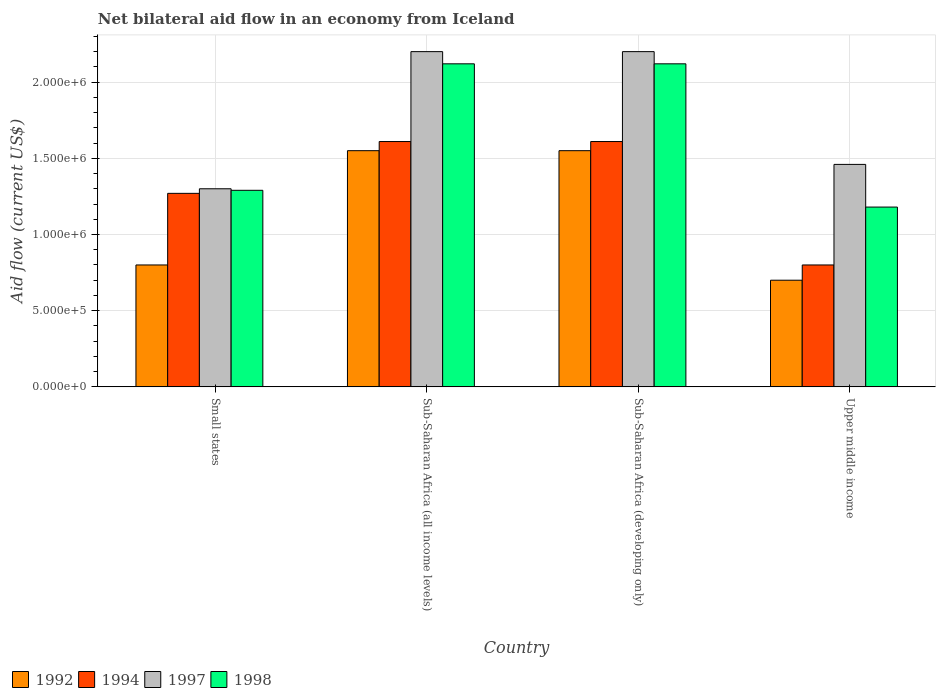How many different coloured bars are there?
Your answer should be very brief. 4. Are the number of bars per tick equal to the number of legend labels?
Your response must be concise. Yes. What is the label of the 4th group of bars from the left?
Make the answer very short. Upper middle income. What is the net bilateral aid flow in 1997 in Upper middle income?
Your response must be concise. 1.46e+06. Across all countries, what is the maximum net bilateral aid flow in 1992?
Make the answer very short. 1.55e+06. In which country was the net bilateral aid flow in 1994 maximum?
Provide a succinct answer. Sub-Saharan Africa (all income levels). In which country was the net bilateral aid flow in 1997 minimum?
Offer a very short reply. Small states. What is the total net bilateral aid flow in 1997 in the graph?
Make the answer very short. 7.16e+06. What is the difference between the net bilateral aid flow in 1998 in Small states and that in Sub-Saharan Africa (all income levels)?
Provide a short and direct response. -8.30e+05. What is the average net bilateral aid flow in 1992 per country?
Your answer should be very brief. 1.15e+06. What is the difference between the net bilateral aid flow of/in 1997 and net bilateral aid flow of/in 1998 in Sub-Saharan Africa (all income levels)?
Make the answer very short. 8.00e+04. What is the ratio of the net bilateral aid flow in 1992 in Small states to that in Sub-Saharan Africa (all income levels)?
Provide a short and direct response. 0.52. Is the net bilateral aid flow in 1994 in Small states less than that in Sub-Saharan Africa (all income levels)?
Your answer should be compact. Yes. Is the difference between the net bilateral aid flow in 1997 in Small states and Sub-Saharan Africa (all income levels) greater than the difference between the net bilateral aid flow in 1998 in Small states and Sub-Saharan Africa (all income levels)?
Make the answer very short. No. What is the difference between the highest and the second highest net bilateral aid flow in 1992?
Offer a very short reply. 7.50e+05. What is the difference between the highest and the lowest net bilateral aid flow in 1998?
Keep it short and to the point. 9.40e+05. In how many countries, is the net bilateral aid flow in 1998 greater than the average net bilateral aid flow in 1998 taken over all countries?
Your answer should be compact. 2. Is it the case that in every country, the sum of the net bilateral aid flow in 1997 and net bilateral aid flow in 1998 is greater than the sum of net bilateral aid flow in 1992 and net bilateral aid flow in 1994?
Offer a very short reply. No. How many bars are there?
Your answer should be very brief. 16. Are the values on the major ticks of Y-axis written in scientific E-notation?
Make the answer very short. Yes. Does the graph contain any zero values?
Offer a very short reply. No. Does the graph contain grids?
Ensure brevity in your answer.  Yes. How are the legend labels stacked?
Ensure brevity in your answer.  Horizontal. What is the title of the graph?
Your response must be concise. Net bilateral aid flow in an economy from Iceland. What is the label or title of the X-axis?
Your response must be concise. Country. What is the label or title of the Y-axis?
Provide a short and direct response. Aid flow (current US$). What is the Aid flow (current US$) of 1992 in Small states?
Give a very brief answer. 8.00e+05. What is the Aid flow (current US$) of 1994 in Small states?
Ensure brevity in your answer.  1.27e+06. What is the Aid flow (current US$) of 1997 in Small states?
Keep it short and to the point. 1.30e+06. What is the Aid flow (current US$) of 1998 in Small states?
Make the answer very short. 1.29e+06. What is the Aid flow (current US$) of 1992 in Sub-Saharan Africa (all income levels)?
Your answer should be compact. 1.55e+06. What is the Aid flow (current US$) of 1994 in Sub-Saharan Africa (all income levels)?
Make the answer very short. 1.61e+06. What is the Aid flow (current US$) of 1997 in Sub-Saharan Africa (all income levels)?
Offer a very short reply. 2.20e+06. What is the Aid flow (current US$) of 1998 in Sub-Saharan Africa (all income levels)?
Your response must be concise. 2.12e+06. What is the Aid flow (current US$) of 1992 in Sub-Saharan Africa (developing only)?
Your answer should be very brief. 1.55e+06. What is the Aid flow (current US$) of 1994 in Sub-Saharan Africa (developing only)?
Ensure brevity in your answer.  1.61e+06. What is the Aid flow (current US$) of 1997 in Sub-Saharan Africa (developing only)?
Give a very brief answer. 2.20e+06. What is the Aid flow (current US$) in 1998 in Sub-Saharan Africa (developing only)?
Your answer should be compact. 2.12e+06. What is the Aid flow (current US$) in 1992 in Upper middle income?
Provide a succinct answer. 7.00e+05. What is the Aid flow (current US$) in 1994 in Upper middle income?
Ensure brevity in your answer.  8.00e+05. What is the Aid flow (current US$) of 1997 in Upper middle income?
Your answer should be very brief. 1.46e+06. What is the Aid flow (current US$) in 1998 in Upper middle income?
Provide a short and direct response. 1.18e+06. Across all countries, what is the maximum Aid flow (current US$) of 1992?
Give a very brief answer. 1.55e+06. Across all countries, what is the maximum Aid flow (current US$) in 1994?
Provide a succinct answer. 1.61e+06. Across all countries, what is the maximum Aid flow (current US$) of 1997?
Keep it short and to the point. 2.20e+06. Across all countries, what is the maximum Aid flow (current US$) of 1998?
Your answer should be very brief. 2.12e+06. Across all countries, what is the minimum Aid flow (current US$) in 1997?
Offer a very short reply. 1.30e+06. Across all countries, what is the minimum Aid flow (current US$) of 1998?
Provide a short and direct response. 1.18e+06. What is the total Aid flow (current US$) in 1992 in the graph?
Your response must be concise. 4.60e+06. What is the total Aid flow (current US$) in 1994 in the graph?
Provide a succinct answer. 5.29e+06. What is the total Aid flow (current US$) of 1997 in the graph?
Offer a terse response. 7.16e+06. What is the total Aid flow (current US$) of 1998 in the graph?
Offer a very short reply. 6.71e+06. What is the difference between the Aid flow (current US$) in 1992 in Small states and that in Sub-Saharan Africa (all income levels)?
Keep it short and to the point. -7.50e+05. What is the difference between the Aid flow (current US$) in 1994 in Small states and that in Sub-Saharan Africa (all income levels)?
Keep it short and to the point. -3.40e+05. What is the difference between the Aid flow (current US$) in 1997 in Small states and that in Sub-Saharan Africa (all income levels)?
Offer a very short reply. -9.00e+05. What is the difference between the Aid flow (current US$) of 1998 in Small states and that in Sub-Saharan Africa (all income levels)?
Give a very brief answer. -8.30e+05. What is the difference between the Aid flow (current US$) in 1992 in Small states and that in Sub-Saharan Africa (developing only)?
Ensure brevity in your answer.  -7.50e+05. What is the difference between the Aid flow (current US$) of 1997 in Small states and that in Sub-Saharan Africa (developing only)?
Your answer should be compact. -9.00e+05. What is the difference between the Aid flow (current US$) in 1998 in Small states and that in Sub-Saharan Africa (developing only)?
Your answer should be very brief. -8.30e+05. What is the difference between the Aid flow (current US$) in 1994 in Small states and that in Upper middle income?
Your answer should be compact. 4.70e+05. What is the difference between the Aid flow (current US$) in 1992 in Sub-Saharan Africa (all income levels) and that in Sub-Saharan Africa (developing only)?
Provide a succinct answer. 0. What is the difference between the Aid flow (current US$) in 1992 in Sub-Saharan Africa (all income levels) and that in Upper middle income?
Give a very brief answer. 8.50e+05. What is the difference between the Aid flow (current US$) of 1994 in Sub-Saharan Africa (all income levels) and that in Upper middle income?
Offer a very short reply. 8.10e+05. What is the difference between the Aid flow (current US$) in 1997 in Sub-Saharan Africa (all income levels) and that in Upper middle income?
Keep it short and to the point. 7.40e+05. What is the difference between the Aid flow (current US$) of 1998 in Sub-Saharan Africa (all income levels) and that in Upper middle income?
Keep it short and to the point. 9.40e+05. What is the difference between the Aid flow (current US$) in 1992 in Sub-Saharan Africa (developing only) and that in Upper middle income?
Your response must be concise. 8.50e+05. What is the difference between the Aid flow (current US$) of 1994 in Sub-Saharan Africa (developing only) and that in Upper middle income?
Provide a succinct answer. 8.10e+05. What is the difference between the Aid flow (current US$) of 1997 in Sub-Saharan Africa (developing only) and that in Upper middle income?
Give a very brief answer. 7.40e+05. What is the difference between the Aid flow (current US$) in 1998 in Sub-Saharan Africa (developing only) and that in Upper middle income?
Your answer should be very brief. 9.40e+05. What is the difference between the Aid flow (current US$) in 1992 in Small states and the Aid flow (current US$) in 1994 in Sub-Saharan Africa (all income levels)?
Keep it short and to the point. -8.10e+05. What is the difference between the Aid flow (current US$) of 1992 in Small states and the Aid flow (current US$) of 1997 in Sub-Saharan Africa (all income levels)?
Keep it short and to the point. -1.40e+06. What is the difference between the Aid flow (current US$) of 1992 in Small states and the Aid flow (current US$) of 1998 in Sub-Saharan Africa (all income levels)?
Offer a very short reply. -1.32e+06. What is the difference between the Aid flow (current US$) of 1994 in Small states and the Aid flow (current US$) of 1997 in Sub-Saharan Africa (all income levels)?
Offer a terse response. -9.30e+05. What is the difference between the Aid flow (current US$) in 1994 in Small states and the Aid flow (current US$) in 1998 in Sub-Saharan Africa (all income levels)?
Provide a succinct answer. -8.50e+05. What is the difference between the Aid flow (current US$) of 1997 in Small states and the Aid flow (current US$) of 1998 in Sub-Saharan Africa (all income levels)?
Keep it short and to the point. -8.20e+05. What is the difference between the Aid flow (current US$) of 1992 in Small states and the Aid flow (current US$) of 1994 in Sub-Saharan Africa (developing only)?
Your answer should be very brief. -8.10e+05. What is the difference between the Aid flow (current US$) of 1992 in Small states and the Aid flow (current US$) of 1997 in Sub-Saharan Africa (developing only)?
Your answer should be compact. -1.40e+06. What is the difference between the Aid flow (current US$) of 1992 in Small states and the Aid flow (current US$) of 1998 in Sub-Saharan Africa (developing only)?
Your answer should be very brief. -1.32e+06. What is the difference between the Aid flow (current US$) of 1994 in Small states and the Aid flow (current US$) of 1997 in Sub-Saharan Africa (developing only)?
Your response must be concise. -9.30e+05. What is the difference between the Aid flow (current US$) of 1994 in Small states and the Aid flow (current US$) of 1998 in Sub-Saharan Africa (developing only)?
Provide a succinct answer. -8.50e+05. What is the difference between the Aid flow (current US$) in 1997 in Small states and the Aid flow (current US$) in 1998 in Sub-Saharan Africa (developing only)?
Your response must be concise. -8.20e+05. What is the difference between the Aid flow (current US$) of 1992 in Small states and the Aid flow (current US$) of 1994 in Upper middle income?
Offer a very short reply. 0. What is the difference between the Aid flow (current US$) in 1992 in Small states and the Aid flow (current US$) in 1997 in Upper middle income?
Ensure brevity in your answer.  -6.60e+05. What is the difference between the Aid flow (current US$) in 1992 in Small states and the Aid flow (current US$) in 1998 in Upper middle income?
Offer a terse response. -3.80e+05. What is the difference between the Aid flow (current US$) of 1994 in Small states and the Aid flow (current US$) of 1997 in Upper middle income?
Ensure brevity in your answer.  -1.90e+05. What is the difference between the Aid flow (current US$) of 1992 in Sub-Saharan Africa (all income levels) and the Aid flow (current US$) of 1997 in Sub-Saharan Africa (developing only)?
Your answer should be compact. -6.50e+05. What is the difference between the Aid flow (current US$) of 1992 in Sub-Saharan Africa (all income levels) and the Aid flow (current US$) of 1998 in Sub-Saharan Africa (developing only)?
Your answer should be compact. -5.70e+05. What is the difference between the Aid flow (current US$) in 1994 in Sub-Saharan Africa (all income levels) and the Aid flow (current US$) in 1997 in Sub-Saharan Africa (developing only)?
Give a very brief answer. -5.90e+05. What is the difference between the Aid flow (current US$) in 1994 in Sub-Saharan Africa (all income levels) and the Aid flow (current US$) in 1998 in Sub-Saharan Africa (developing only)?
Make the answer very short. -5.10e+05. What is the difference between the Aid flow (current US$) in 1997 in Sub-Saharan Africa (all income levels) and the Aid flow (current US$) in 1998 in Sub-Saharan Africa (developing only)?
Offer a terse response. 8.00e+04. What is the difference between the Aid flow (current US$) in 1992 in Sub-Saharan Africa (all income levels) and the Aid flow (current US$) in 1994 in Upper middle income?
Offer a very short reply. 7.50e+05. What is the difference between the Aid flow (current US$) of 1992 in Sub-Saharan Africa (all income levels) and the Aid flow (current US$) of 1998 in Upper middle income?
Your answer should be very brief. 3.70e+05. What is the difference between the Aid flow (current US$) in 1997 in Sub-Saharan Africa (all income levels) and the Aid flow (current US$) in 1998 in Upper middle income?
Give a very brief answer. 1.02e+06. What is the difference between the Aid flow (current US$) in 1992 in Sub-Saharan Africa (developing only) and the Aid flow (current US$) in 1994 in Upper middle income?
Provide a short and direct response. 7.50e+05. What is the difference between the Aid flow (current US$) in 1992 in Sub-Saharan Africa (developing only) and the Aid flow (current US$) in 1997 in Upper middle income?
Offer a terse response. 9.00e+04. What is the difference between the Aid flow (current US$) in 1992 in Sub-Saharan Africa (developing only) and the Aid flow (current US$) in 1998 in Upper middle income?
Offer a very short reply. 3.70e+05. What is the difference between the Aid flow (current US$) in 1994 in Sub-Saharan Africa (developing only) and the Aid flow (current US$) in 1998 in Upper middle income?
Provide a short and direct response. 4.30e+05. What is the difference between the Aid flow (current US$) in 1997 in Sub-Saharan Africa (developing only) and the Aid flow (current US$) in 1998 in Upper middle income?
Ensure brevity in your answer.  1.02e+06. What is the average Aid flow (current US$) of 1992 per country?
Your answer should be very brief. 1.15e+06. What is the average Aid flow (current US$) in 1994 per country?
Offer a terse response. 1.32e+06. What is the average Aid flow (current US$) in 1997 per country?
Ensure brevity in your answer.  1.79e+06. What is the average Aid flow (current US$) in 1998 per country?
Ensure brevity in your answer.  1.68e+06. What is the difference between the Aid flow (current US$) in 1992 and Aid flow (current US$) in 1994 in Small states?
Make the answer very short. -4.70e+05. What is the difference between the Aid flow (current US$) in 1992 and Aid flow (current US$) in 1997 in Small states?
Your answer should be compact. -5.00e+05. What is the difference between the Aid flow (current US$) in 1992 and Aid flow (current US$) in 1998 in Small states?
Make the answer very short. -4.90e+05. What is the difference between the Aid flow (current US$) of 1997 and Aid flow (current US$) of 1998 in Small states?
Ensure brevity in your answer.  10000. What is the difference between the Aid flow (current US$) in 1992 and Aid flow (current US$) in 1994 in Sub-Saharan Africa (all income levels)?
Your response must be concise. -6.00e+04. What is the difference between the Aid flow (current US$) in 1992 and Aid flow (current US$) in 1997 in Sub-Saharan Africa (all income levels)?
Your answer should be very brief. -6.50e+05. What is the difference between the Aid flow (current US$) in 1992 and Aid flow (current US$) in 1998 in Sub-Saharan Africa (all income levels)?
Provide a short and direct response. -5.70e+05. What is the difference between the Aid flow (current US$) of 1994 and Aid flow (current US$) of 1997 in Sub-Saharan Africa (all income levels)?
Provide a succinct answer. -5.90e+05. What is the difference between the Aid flow (current US$) in 1994 and Aid flow (current US$) in 1998 in Sub-Saharan Africa (all income levels)?
Provide a short and direct response. -5.10e+05. What is the difference between the Aid flow (current US$) in 1997 and Aid flow (current US$) in 1998 in Sub-Saharan Africa (all income levels)?
Provide a succinct answer. 8.00e+04. What is the difference between the Aid flow (current US$) of 1992 and Aid flow (current US$) of 1994 in Sub-Saharan Africa (developing only)?
Your answer should be very brief. -6.00e+04. What is the difference between the Aid flow (current US$) in 1992 and Aid flow (current US$) in 1997 in Sub-Saharan Africa (developing only)?
Your answer should be compact. -6.50e+05. What is the difference between the Aid flow (current US$) of 1992 and Aid flow (current US$) of 1998 in Sub-Saharan Africa (developing only)?
Offer a terse response. -5.70e+05. What is the difference between the Aid flow (current US$) of 1994 and Aid flow (current US$) of 1997 in Sub-Saharan Africa (developing only)?
Give a very brief answer. -5.90e+05. What is the difference between the Aid flow (current US$) in 1994 and Aid flow (current US$) in 1998 in Sub-Saharan Africa (developing only)?
Offer a terse response. -5.10e+05. What is the difference between the Aid flow (current US$) of 1992 and Aid flow (current US$) of 1994 in Upper middle income?
Give a very brief answer. -1.00e+05. What is the difference between the Aid flow (current US$) in 1992 and Aid flow (current US$) in 1997 in Upper middle income?
Your response must be concise. -7.60e+05. What is the difference between the Aid flow (current US$) in 1992 and Aid flow (current US$) in 1998 in Upper middle income?
Give a very brief answer. -4.80e+05. What is the difference between the Aid flow (current US$) of 1994 and Aid flow (current US$) of 1997 in Upper middle income?
Provide a short and direct response. -6.60e+05. What is the difference between the Aid flow (current US$) of 1994 and Aid flow (current US$) of 1998 in Upper middle income?
Ensure brevity in your answer.  -3.80e+05. What is the difference between the Aid flow (current US$) of 1997 and Aid flow (current US$) of 1998 in Upper middle income?
Keep it short and to the point. 2.80e+05. What is the ratio of the Aid flow (current US$) of 1992 in Small states to that in Sub-Saharan Africa (all income levels)?
Keep it short and to the point. 0.52. What is the ratio of the Aid flow (current US$) in 1994 in Small states to that in Sub-Saharan Africa (all income levels)?
Your answer should be very brief. 0.79. What is the ratio of the Aid flow (current US$) of 1997 in Small states to that in Sub-Saharan Africa (all income levels)?
Offer a terse response. 0.59. What is the ratio of the Aid flow (current US$) in 1998 in Small states to that in Sub-Saharan Africa (all income levels)?
Give a very brief answer. 0.61. What is the ratio of the Aid flow (current US$) of 1992 in Small states to that in Sub-Saharan Africa (developing only)?
Your answer should be compact. 0.52. What is the ratio of the Aid flow (current US$) in 1994 in Small states to that in Sub-Saharan Africa (developing only)?
Offer a terse response. 0.79. What is the ratio of the Aid flow (current US$) in 1997 in Small states to that in Sub-Saharan Africa (developing only)?
Offer a very short reply. 0.59. What is the ratio of the Aid flow (current US$) in 1998 in Small states to that in Sub-Saharan Africa (developing only)?
Offer a terse response. 0.61. What is the ratio of the Aid flow (current US$) in 1994 in Small states to that in Upper middle income?
Give a very brief answer. 1.59. What is the ratio of the Aid flow (current US$) in 1997 in Small states to that in Upper middle income?
Make the answer very short. 0.89. What is the ratio of the Aid flow (current US$) of 1998 in Small states to that in Upper middle income?
Offer a terse response. 1.09. What is the ratio of the Aid flow (current US$) of 1997 in Sub-Saharan Africa (all income levels) to that in Sub-Saharan Africa (developing only)?
Make the answer very short. 1. What is the ratio of the Aid flow (current US$) of 1998 in Sub-Saharan Africa (all income levels) to that in Sub-Saharan Africa (developing only)?
Your answer should be very brief. 1. What is the ratio of the Aid flow (current US$) in 1992 in Sub-Saharan Africa (all income levels) to that in Upper middle income?
Your answer should be compact. 2.21. What is the ratio of the Aid flow (current US$) of 1994 in Sub-Saharan Africa (all income levels) to that in Upper middle income?
Offer a very short reply. 2.01. What is the ratio of the Aid flow (current US$) of 1997 in Sub-Saharan Africa (all income levels) to that in Upper middle income?
Your response must be concise. 1.51. What is the ratio of the Aid flow (current US$) in 1998 in Sub-Saharan Africa (all income levels) to that in Upper middle income?
Make the answer very short. 1.8. What is the ratio of the Aid flow (current US$) of 1992 in Sub-Saharan Africa (developing only) to that in Upper middle income?
Give a very brief answer. 2.21. What is the ratio of the Aid flow (current US$) in 1994 in Sub-Saharan Africa (developing only) to that in Upper middle income?
Give a very brief answer. 2.01. What is the ratio of the Aid flow (current US$) in 1997 in Sub-Saharan Africa (developing only) to that in Upper middle income?
Provide a short and direct response. 1.51. What is the ratio of the Aid flow (current US$) of 1998 in Sub-Saharan Africa (developing only) to that in Upper middle income?
Provide a short and direct response. 1.8. What is the difference between the highest and the second highest Aid flow (current US$) of 1997?
Offer a terse response. 0. What is the difference between the highest and the lowest Aid flow (current US$) in 1992?
Ensure brevity in your answer.  8.50e+05. What is the difference between the highest and the lowest Aid flow (current US$) of 1994?
Your answer should be very brief. 8.10e+05. What is the difference between the highest and the lowest Aid flow (current US$) in 1997?
Keep it short and to the point. 9.00e+05. What is the difference between the highest and the lowest Aid flow (current US$) in 1998?
Offer a terse response. 9.40e+05. 